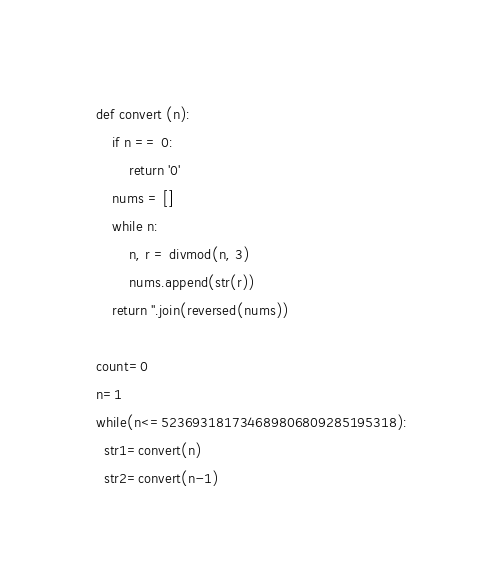Convert code to text. <code><loc_0><loc_0><loc_500><loc_500><_Python_>def convert (n):
    if n == 0:
        return '0'
    nums = []
    while n:
        n, r = divmod(n, 3)
        nums.append(str(r))
    return ''.join(reversed(nums))

count=0
n=1
while(n<=523693181734689806809285195318):
  str1=convert(n)
  str2=convert(n-1)</code> 